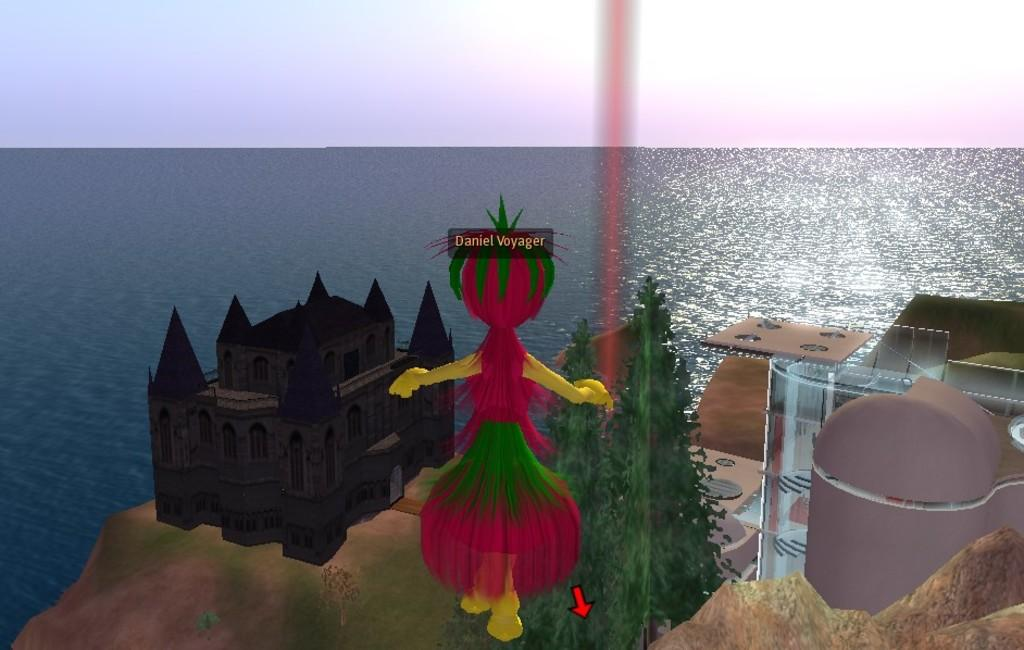What type of image is depicted in the center of the image? There is a graphical image of a building in the image. Are there any living beings present in the image? Yes, there is a graphical image of a person in the image. What type of natural environment is visible in the image? There is a group of trees and water visible in the image. What part of the natural environment is visible in the image? The sky is visible in the image. What type of insurance policy is the person holding in the image? There is no person holding an insurance policy in the image; it features a graphical image of a person. Can you tell me how many fish are swimming in the water in the image? There are no fish visible in the image; it features a group of trees and water. 